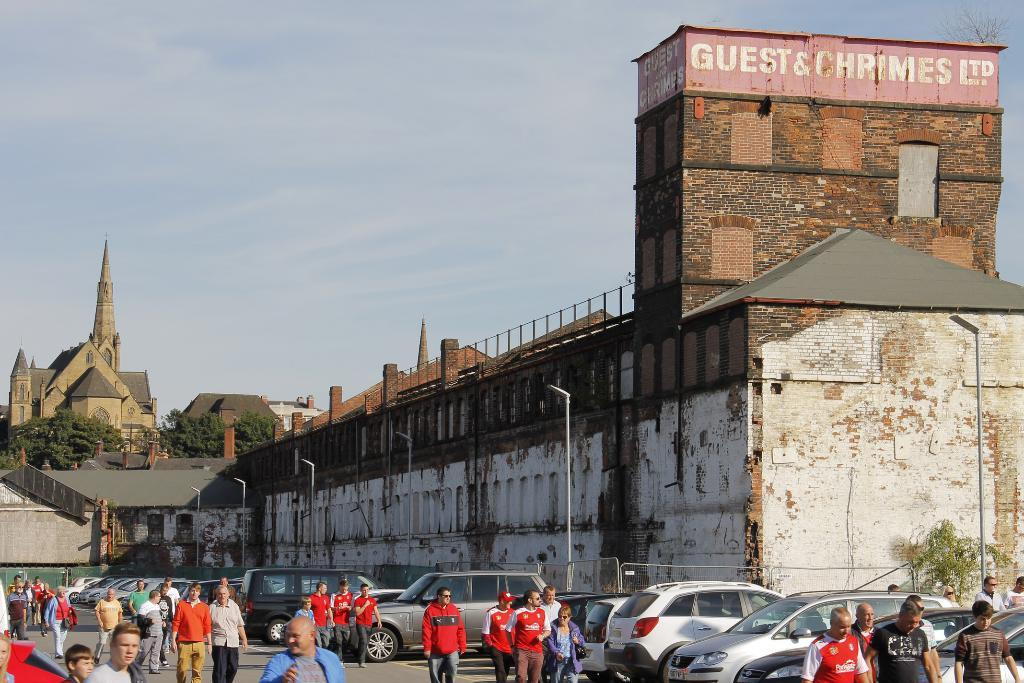What are the people in the image doing? The people in the image are walking on the road. What else can be seen on the road in the image? There are vehicles on the road in the image. What structures are present along the road in the image? There are light poles, trees, and buildings in the image. What type of barrier is present along the road in the image? There is fencing in the image. What can be seen in the sky in the image? The sky is visible in the image. What type of flesh can be seen on the light poles in the image? There is no flesh present on the light poles in the image. Are the people in the image fighting with each other? There is no indication in the image that the people are fighting; they are simply walking on the road. 